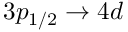Convert formula to latex. <formula><loc_0><loc_0><loc_500><loc_500>3 p _ { 1 / 2 } \rightarrow 4 d</formula> 